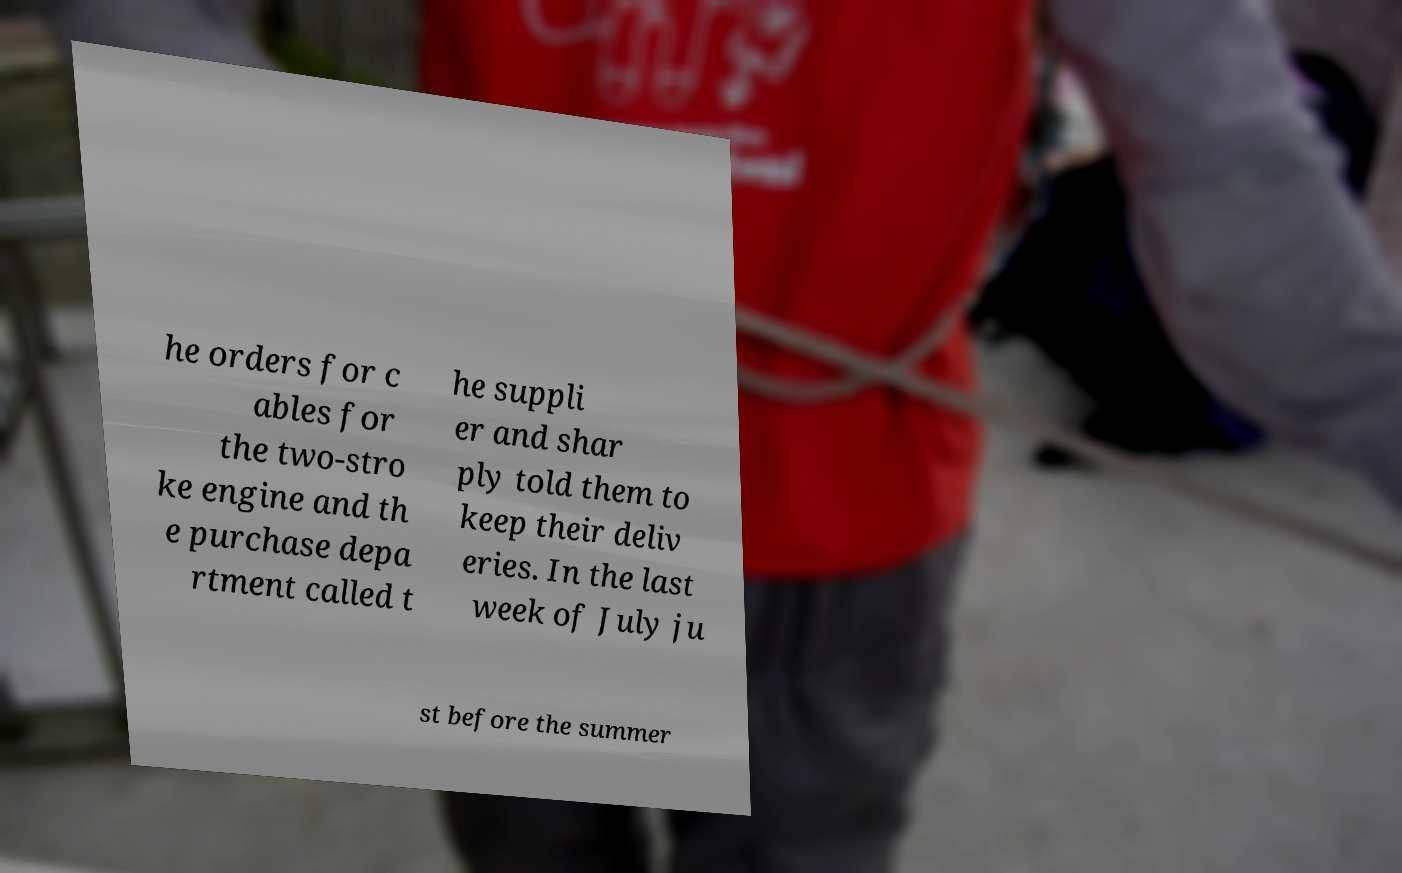What messages or text are displayed in this image? I need them in a readable, typed format. he orders for c ables for the two-stro ke engine and th e purchase depa rtment called t he suppli er and shar ply told them to keep their deliv eries. In the last week of July ju st before the summer 